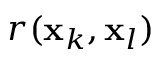<formula> <loc_0><loc_0><loc_500><loc_500>r ( x _ { k } , x _ { l } )</formula> 